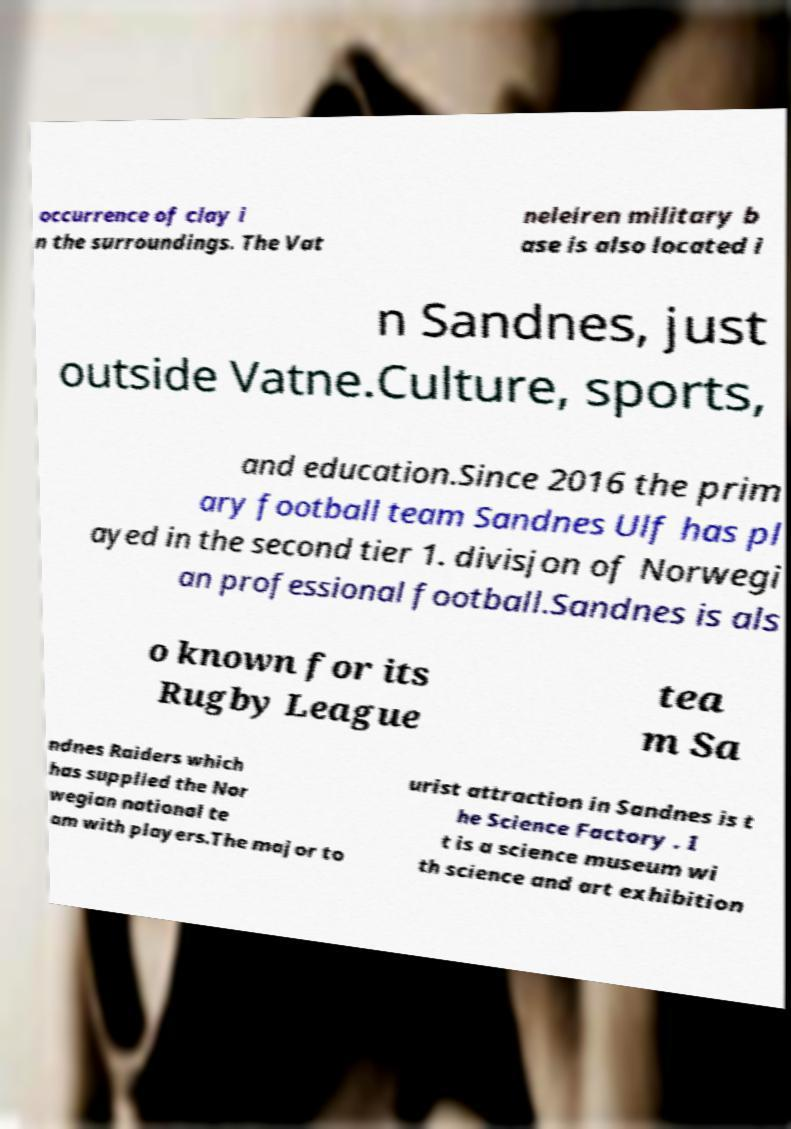What messages or text are displayed in this image? I need them in a readable, typed format. occurrence of clay i n the surroundings. The Vat neleiren military b ase is also located i n Sandnes, just outside Vatne.Culture, sports, and education.Since 2016 the prim ary football team Sandnes Ulf has pl ayed in the second tier 1. divisjon of Norwegi an professional football.Sandnes is als o known for its Rugby League tea m Sa ndnes Raiders which has supplied the Nor wegian national te am with players.The major to urist attraction in Sandnes is t he Science Factory . I t is a science museum wi th science and art exhibition 